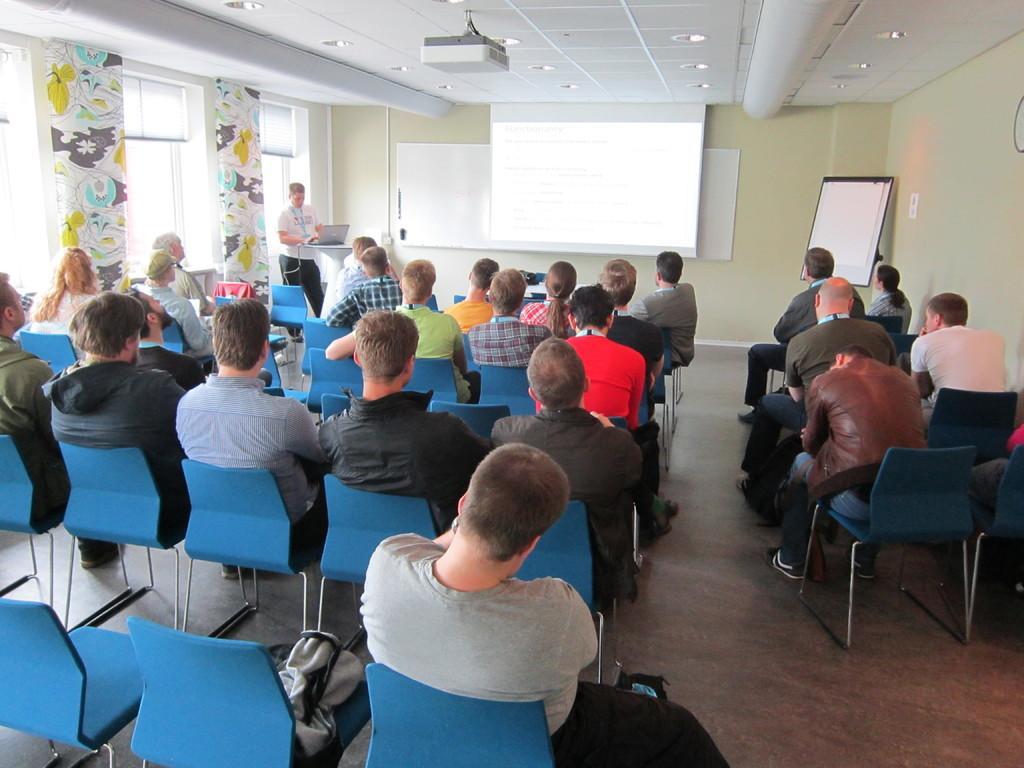Could you give a brief overview of what you see in this image? In this picture there are many people sitting in the chairs. There is a man standing near the podium on which a laptop is placed. In the background there is a projector display screen, wall and a board here. 